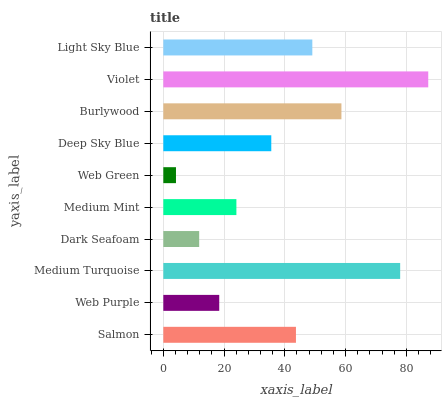Is Web Green the minimum?
Answer yes or no. Yes. Is Violet the maximum?
Answer yes or no. Yes. Is Web Purple the minimum?
Answer yes or no. No. Is Web Purple the maximum?
Answer yes or no. No. Is Salmon greater than Web Purple?
Answer yes or no. Yes. Is Web Purple less than Salmon?
Answer yes or no. Yes. Is Web Purple greater than Salmon?
Answer yes or no. No. Is Salmon less than Web Purple?
Answer yes or no. No. Is Salmon the high median?
Answer yes or no. Yes. Is Deep Sky Blue the low median?
Answer yes or no. Yes. Is Web Purple the high median?
Answer yes or no. No. Is Dark Seafoam the low median?
Answer yes or no. No. 